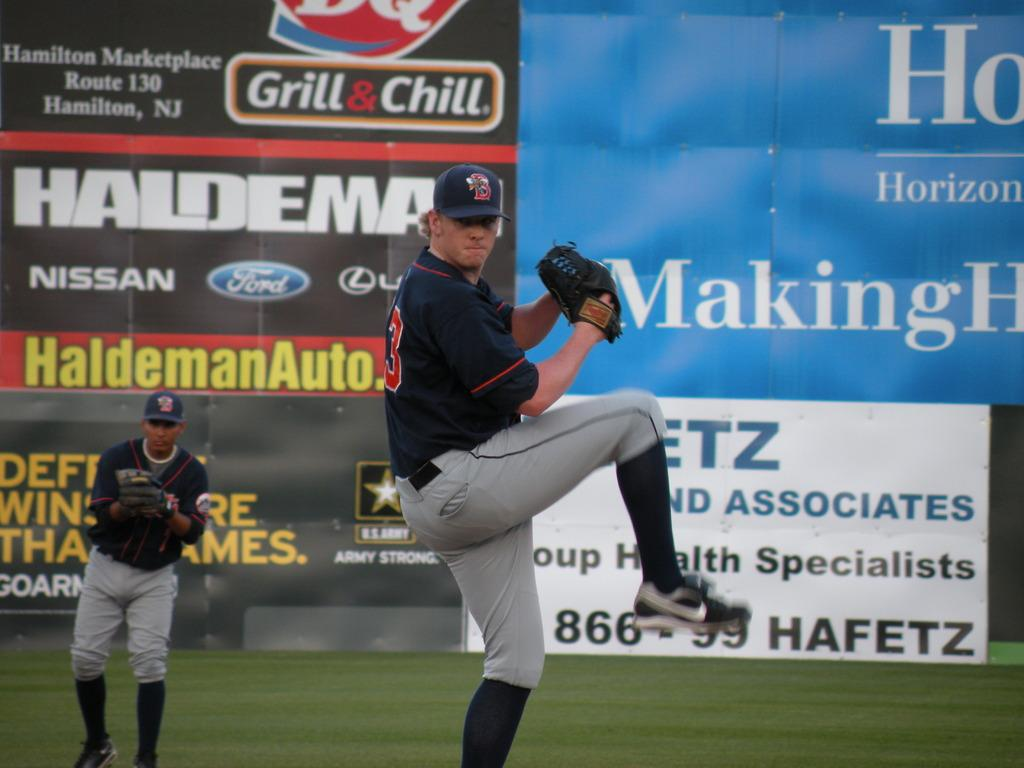<image>
Present a compact description of the photo's key features. A baseball player is pitching a ball in front of a Dairy Queen advertisement. 